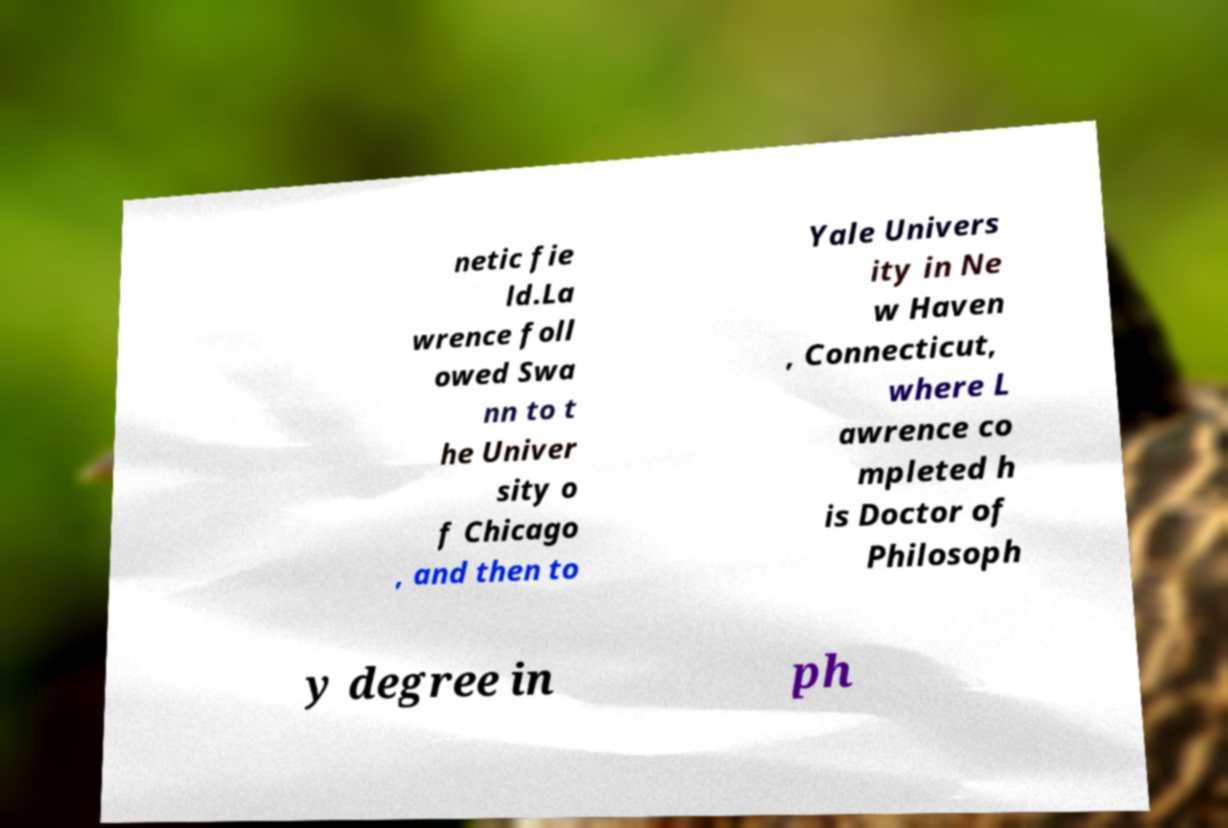Please read and relay the text visible in this image. What does it say? netic fie ld.La wrence foll owed Swa nn to t he Univer sity o f Chicago , and then to Yale Univers ity in Ne w Haven , Connecticut, where L awrence co mpleted h is Doctor of Philosoph y degree in ph 